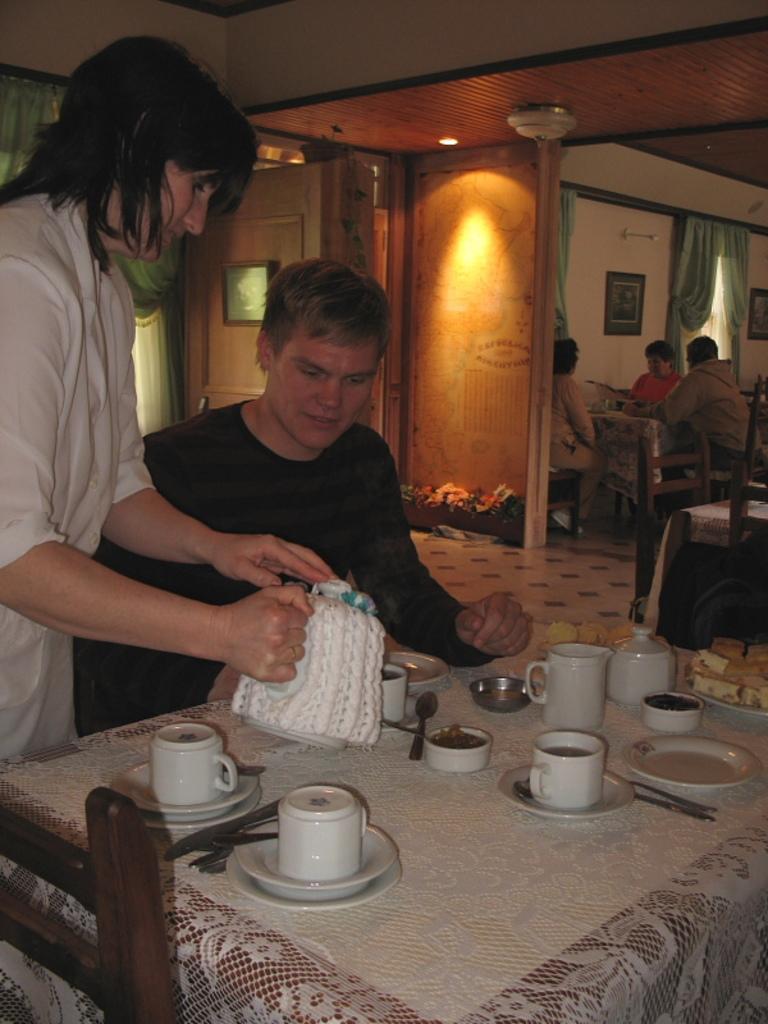Can you describe this image briefly? A picture of a restaurant. This person is sitting on a chair, in-front of this person there is a table, on a table there are spoon, cup, saucer, bowl and knife. This woman is standing and holding a coffee pot. Far there are people sitting on a chair. Light is attached to a roof. Curtain. On wall there are different types of pictures. 